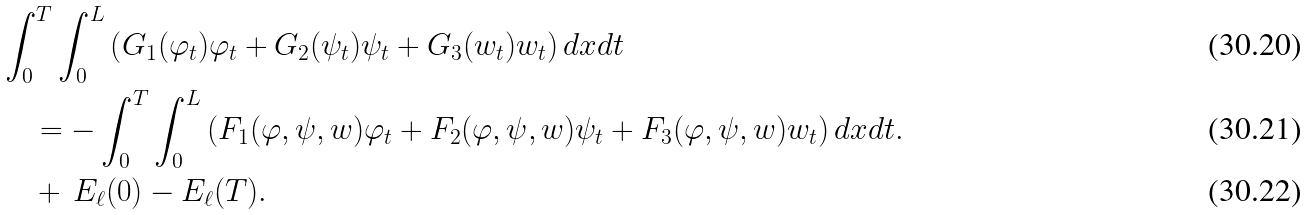Convert formula to latex. <formula><loc_0><loc_0><loc_500><loc_500>& \int _ { 0 } ^ { T } \int _ { 0 } ^ { L } \left ( G _ { 1 } ( \varphi _ { t } ) \varphi _ { t } + G _ { 2 } ( \psi _ { t } ) \psi _ { t } + G _ { 3 } ( w _ { t } ) w _ { t } \right ) d x d t \\ & \quad = - \int _ { 0 } ^ { T } \int _ { 0 } ^ { L } \left ( F _ { 1 } ( \varphi , \psi , w ) \varphi _ { t } + F _ { 2 } ( \varphi , \psi , w ) \psi _ { t } + F _ { 3 } ( \varphi , \psi , w ) w _ { t } \right ) d x d t . \\ & \quad + \, E _ { \ell } ( 0 ) - E _ { \ell } ( T ) .</formula> 